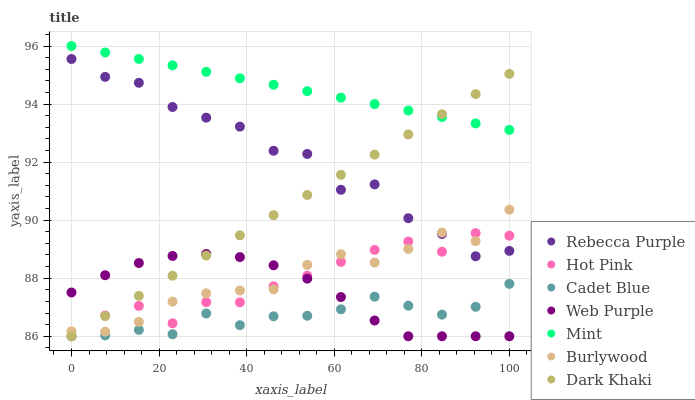Does Cadet Blue have the minimum area under the curve?
Answer yes or no. Yes. Does Mint have the maximum area under the curve?
Answer yes or no. Yes. Does Burlywood have the minimum area under the curve?
Answer yes or no. No. Does Burlywood have the maximum area under the curve?
Answer yes or no. No. Is Mint the smoothest?
Answer yes or no. Yes. Is Rebecca Purple the roughest?
Answer yes or no. Yes. Is Burlywood the smoothest?
Answer yes or no. No. Is Burlywood the roughest?
Answer yes or no. No. Does Cadet Blue have the lowest value?
Answer yes or no. Yes. Does Burlywood have the lowest value?
Answer yes or no. No. Does Mint have the highest value?
Answer yes or no. Yes. Does Burlywood have the highest value?
Answer yes or no. No. Is Cadet Blue less than Rebecca Purple?
Answer yes or no. Yes. Is Mint greater than Hot Pink?
Answer yes or no. Yes. Does Mint intersect Dark Khaki?
Answer yes or no. Yes. Is Mint less than Dark Khaki?
Answer yes or no. No. Is Mint greater than Dark Khaki?
Answer yes or no. No. Does Cadet Blue intersect Rebecca Purple?
Answer yes or no. No. 